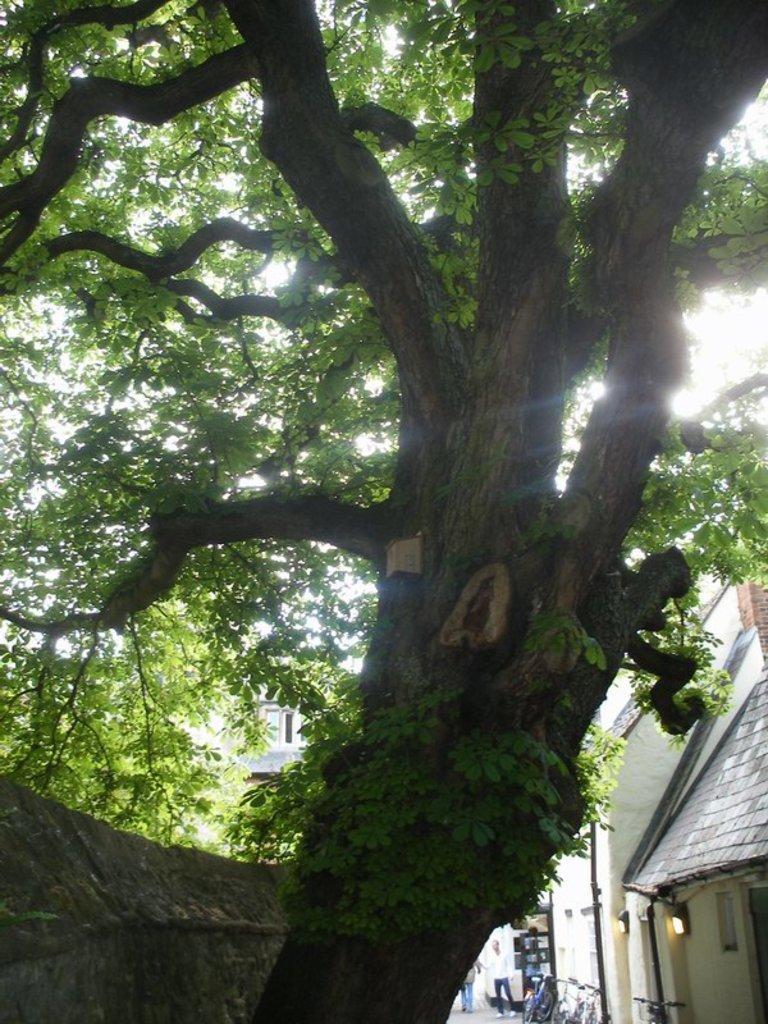Could you give a brief overview of what you see in this image? Here we can see a tree. In the background there are houses,two persons and bicycles on the road,poles,light on the wall,windows and sky. 